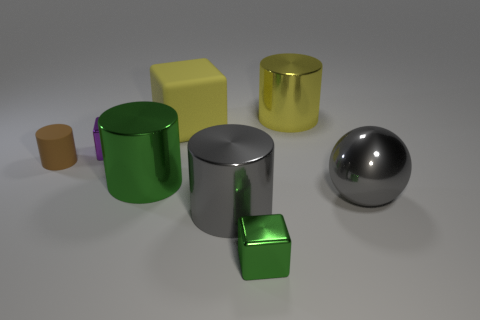Subtract all rubber cylinders. How many cylinders are left? 3 Add 1 tiny brown rubber objects. How many objects exist? 9 Subtract 2 cylinders. How many cylinders are left? 2 Subtract all yellow cubes. How many cubes are left? 2 Subtract all balls. How many objects are left? 7 Add 8 small green cubes. How many small green cubes are left? 9 Add 5 tiny yellow things. How many tiny yellow things exist? 5 Subtract 1 yellow cylinders. How many objects are left? 7 Subtract all red cylinders. Subtract all gray cubes. How many cylinders are left? 4 Subtract all large yellow cylinders. Subtract all big yellow metal objects. How many objects are left? 6 